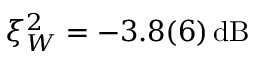<formula> <loc_0><loc_0><loc_500><loc_500>\xi _ { W } ^ { 2 } = - 3 . 8 ( 6 ) \, d B</formula> 